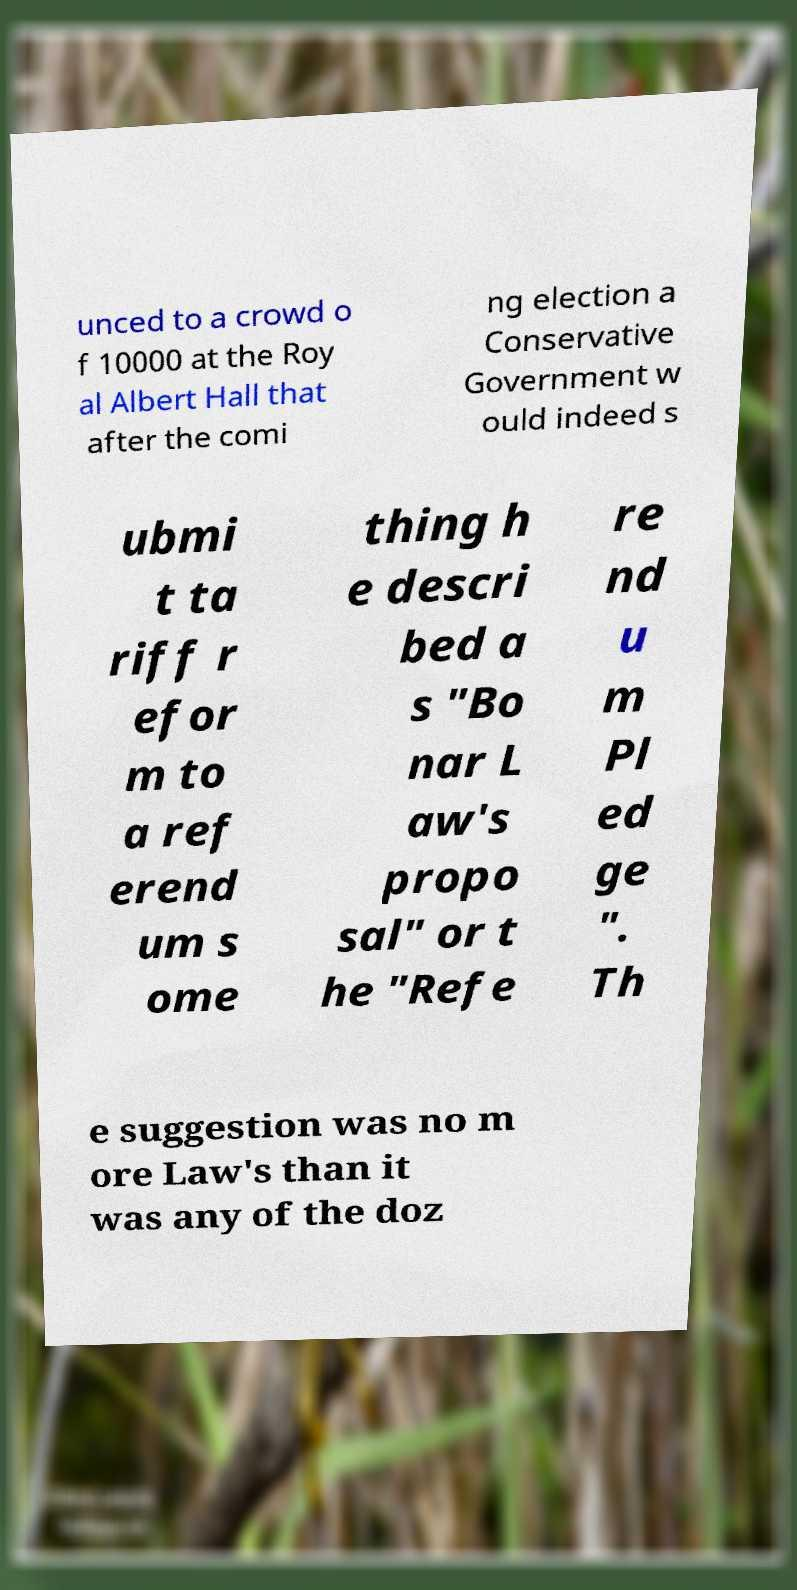For documentation purposes, I need the text within this image transcribed. Could you provide that? unced to a crowd o f 10000 at the Roy al Albert Hall that after the comi ng election a Conservative Government w ould indeed s ubmi t ta riff r efor m to a ref erend um s ome thing h e descri bed a s "Bo nar L aw's propo sal" or t he "Refe re nd u m Pl ed ge ". Th e suggestion was no m ore Law's than it was any of the doz 